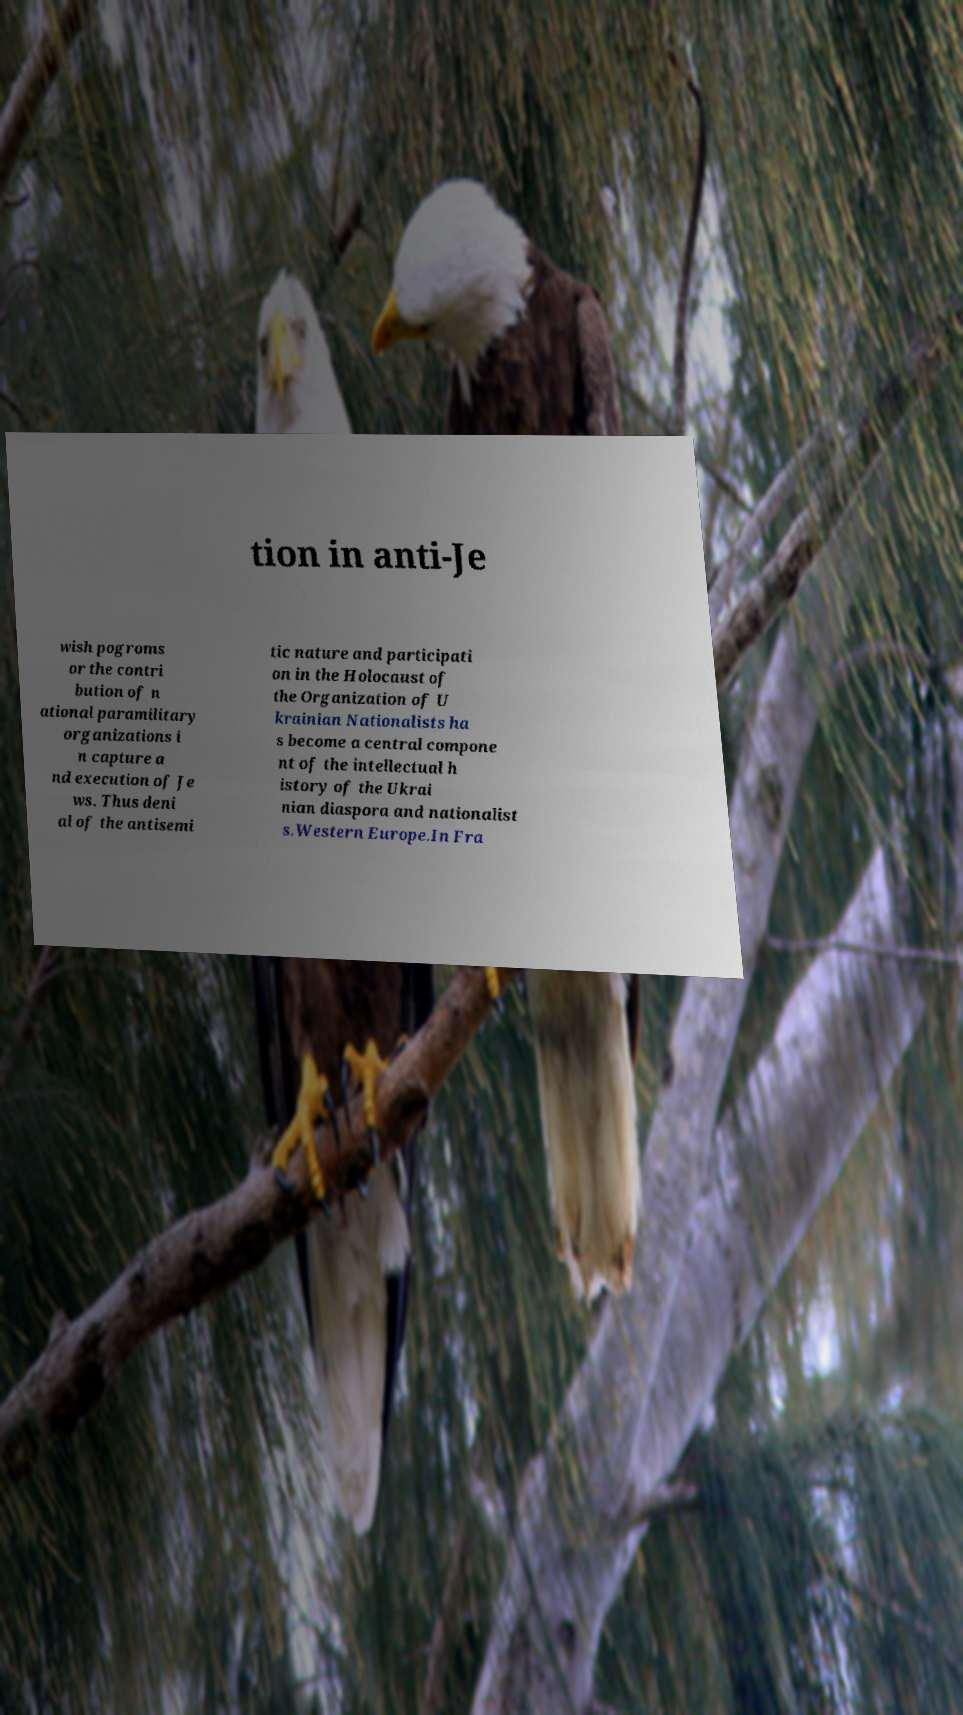There's text embedded in this image that I need extracted. Can you transcribe it verbatim? tion in anti-Je wish pogroms or the contri bution of n ational paramilitary organizations i n capture a nd execution of Je ws. Thus deni al of the antisemi tic nature and participati on in the Holocaust of the Organization of U krainian Nationalists ha s become a central compone nt of the intellectual h istory of the Ukrai nian diaspora and nationalist s.Western Europe.In Fra 